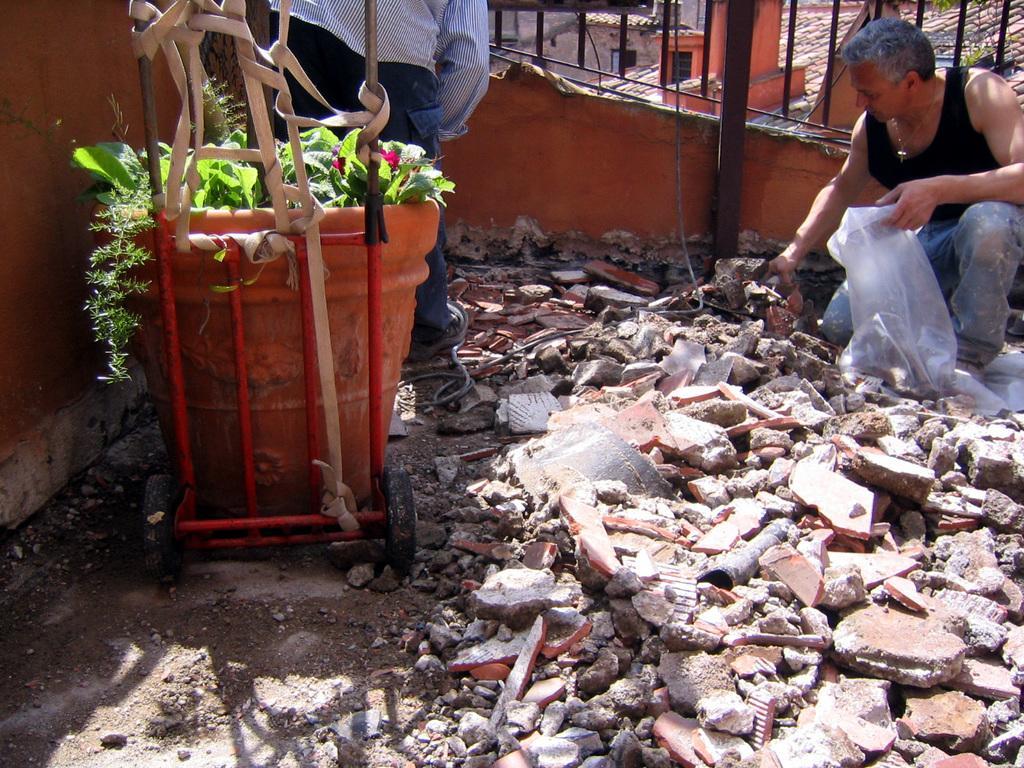Could you give a brief overview of what you see in this image? In this image there are two men. The man to the right is kneeling on the floor. There is a plastic cover in his hand. To the left there is another man bending forward. Behind him there is a flower pot. There are pieces of a broken wall on the ground. Behind them there is a railing. There are plants in the flower pot. 